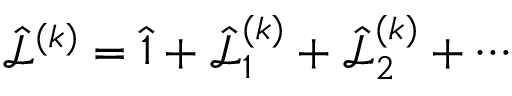<formula> <loc_0><loc_0><loc_500><loc_500>\hat { \mathcal { L } } ^ { ( k ) } = \hat { 1 } + \hat { \mathcal { L } } _ { 1 } ^ { ( k ) } + \hat { \mathcal { L } } _ { 2 } ^ { ( k ) } + \cdots</formula> 